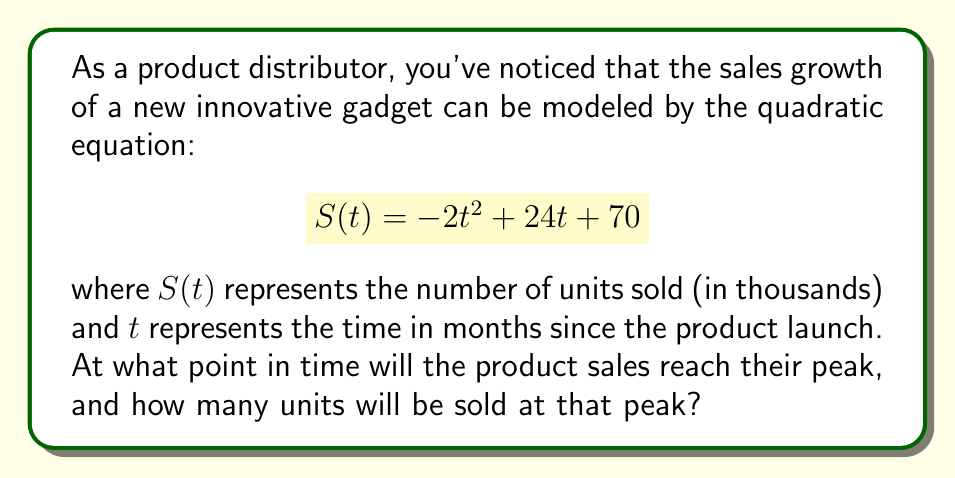Give your solution to this math problem. To solve this problem, we need to follow these steps:

1) The sales function $S(t)$ is a quadratic equation in the form $f(t) = at^2 + bt + c$, where $a = -2$, $b = 24$, and $c = 70$.

2) For a quadratic function, the vertex represents the maximum (if $a < 0$) or minimum (if $a > 0$) point. In this case, since $a = -2 < 0$, the vertex will represent the maximum point, which is what we're looking for.

3) To find the vertex, we can use the formula: $t = -\frac{b}{2a}$

   $$t = -\frac{24}{2(-2)} = -\frac{24}{-4} = 6$$

4) This means the sales will peak 6 months after the product launch.

5) To find the number of units sold at the peak, we substitute $t = 6$ into the original equation:

   $$S(6) = -2(6)^2 + 24(6) + 70$$
   $$= -2(36) + 144 + 70$$
   $$= -72 + 144 + 70$$
   $$= 142$$

6) Therefore, at the peak, 142 thousand units will be sold.
Answer: The product sales will reach their peak 6 months after the launch, with 142 thousand units sold at that time. 